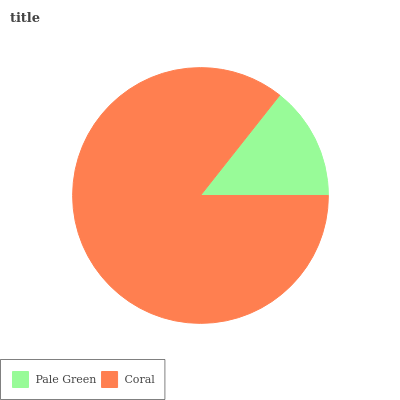Is Pale Green the minimum?
Answer yes or no. Yes. Is Coral the maximum?
Answer yes or no. Yes. Is Coral the minimum?
Answer yes or no. No. Is Coral greater than Pale Green?
Answer yes or no. Yes. Is Pale Green less than Coral?
Answer yes or no. Yes. Is Pale Green greater than Coral?
Answer yes or no. No. Is Coral less than Pale Green?
Answer yes or no. No. Is Coral the high median?
Answer yes or no. Yes. Is Pale Green the low median?
Answer yes or no. Yes. Is Pale Green the high median?
Answer yes or no. No. Is Coral the low median?
Answer yes or no. No. 